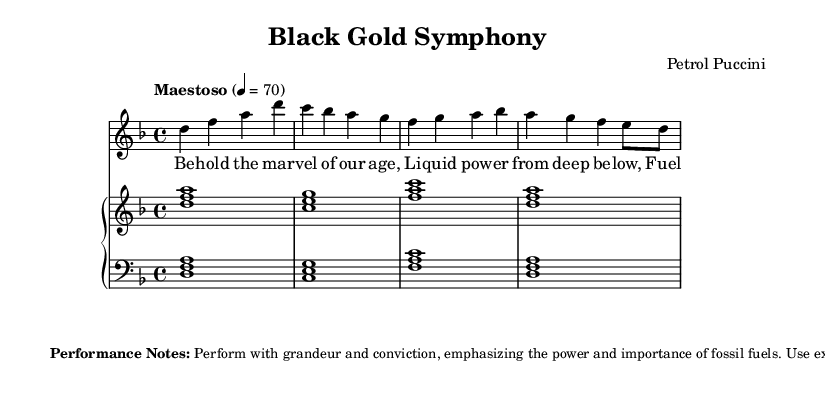What is the key signature of this music? The key signature appears in the global section of the code, where it specifies "d minor". D minor contains one flat (B flat), which can be verified from the written music.
Answer: D minor What is the time signature of this piece? The time signature is provided in the global section, which is specified as "4/4". This means there are four beats in each measure, and the quarter note gets the beat.
Answer: 4/4 What is the tempo marking for this piece? The tempo is indicated in the global section with the phrase "Maestoso" and the beats per minute (4 = 70). This denotes a slow and stately pace for the music.
Answer: Maestoso How many measures are in the soprano part? By counting the measures in the sopranoVoice section, there are a total of four measures indicated by the four sets of vertical bars, each defining a measure.
Answer: 4 What is the name of the composer of this opera? The composer's name is provided in the header section as "Petrol Puccini", which is a play on words referencing the famous composer Puccini and fossil fuels.
Answer: Petrol Puccini What is the primary theme expressed in the soprano lyrics? The soprano lyrics emphasize the significance of fossil fuels, promoting ideas of progress and the importance of oil, as expressed in phrases like "Behold the marvel of our age".
Answer: Marvel of our age What kind of performance style is suggested in the performance notes? The performance notes describe the desired style as "grand" and "conviction", emphasizing the power and importance of fossil fuels, which suggests a highly emotional and dramatic rendition.
Answer: Grand and conviction 